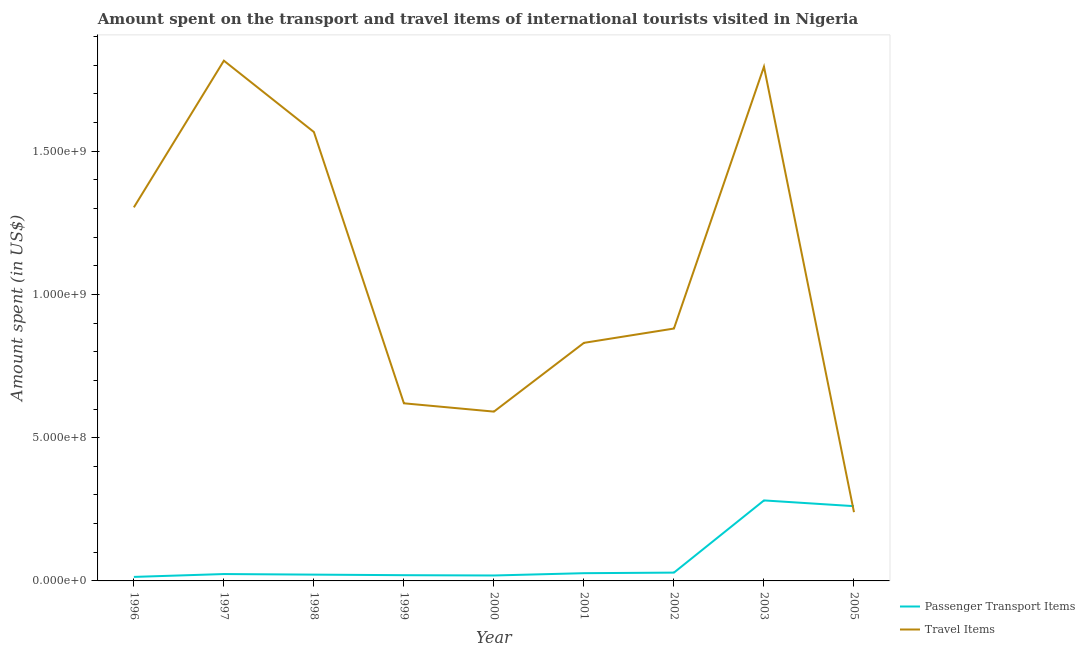How many different coloured lines are there?
Your answer should be compact. 2. Is the number of lines equal to the number of legend labels?
Make the answer very short. Yes. What is the amount spent on passenger transport items in 2002?
Give a very brief answer. 2.90e+07. Across all years, what is the maximum amount spent in travel items?
Offer a very short reply. 1.82e+09. Across all years, what is the minimum amount spent on passenger transport items?
Your response must be concise. 1.40e+07. In which year was the amount spent in travel items maximum?
Your answer should be very brief. 1997. In which year was the amount spent on passenger transport items minimum?
Give a very brief answer. 1996. What is the total amount spent in travel items in the graph?
Give a very brief answer. 9.64e+09. What is the difference between the amount spent in travel items in 2002 and that in 2003?
Provide a succinct answer. -9.14e+08. What is the difference between the amount spent on passenger transport items in 2003 and the amount spent in travel items in 2005?
Your answer should be compact. 4.10e+07. What is the average amount spent on passenger transport items per year?
Your answer should be compact. 7.74e+07. In the year 1996, what is the difference between the amount spent on passenger transport items and amount spent in travel items?
Your answer should be very brief. -1.29e+09. In how many years, is the amount spent in travel items greater than 100000000 US$?
Your answer should be very brief. 9. What is the ratio of the amount spent on passenger transport items in 2000 to that in 2003?
Your answer should be very brief. 0.07. Is the difference between the amount spent on passenger transport items in 2000 and 2002 greater than the difference between the amount spent in travel items in 2000 and 2002?
Your answer should be very brief. Yes. What is the difference between the highest and the second highest amount spent on passenger transport items?
Provide a succinct answer. 2.00e+07. What is the difference between the highest and the lowest amount spent on passenger transport items?
Ensure brevity in your answer.  2.67e+08. Is the amount spent on passenger transport items strictly less than the amount spent in travel items over the years?
Keep it short and to the point. No. How many years are there in the graph?
Ensure brevity in your answer.  9. Does the graph contain any zero values?
Offer a terse response. No. Does the graph contain grids?
Your answer should be very brief. No. Where does the legend appear in the graph?
Keep it short and to the point. Bottom right. How are the legend labels stacked?
Your response must be concise. Vertical. What is the title of the graph?
Your answer should be compact. Amount spent on the transport and travel items of international tourists visited in Nigeria. What is the label or title of the Y-axis?
Ensure brevity in your answer.  Amount spent (in US$). What is the Amount spent (in US$) in Passenger Transport Items in 1996?
Provide a short and direct response. 1.40e+07. What is the Amount spent (in US$) in Travel Items in 1996?
Offer a very short reply. 1.30e+09. What is the Amount spent (in US$) in Passenger Transport Items in 1997?
Provide a succinct answer. 2.40e+07. What is the Amount spent (in US$) in Travel Items in 1997?
Make the answer very short. 1.82e+09. What is the Amount spent (in US$) of Passenger Transport Items in 1998?
Make the answer very short. 2.20e+07. What is the Amount spent (in US$) in Travel Items in 1998?
Your answer should be very brief. 1.57e+09. What is the Amount spent (in US$) of Passenger Transport Items in 1999?
Keep it short and to the point. 2.00e+07. What is the Amount spent (in US$) of Travel Items in 1999?
Offer a terse response. 6.20e+08. What is the Amount spent (in US$) in Passenger Transport Items in 2000?
Give a very brief answer. 1.90e+07. What is the Amount spent (in US$) of Travel Items in 2000?
Ensure brevity in your answer.  5.91e+08. What is the Amount spent (in US$) in Passenger Transport Items in 2001?
Make the answer very short. 2.70e+07. What is the Amount spent (in US$) of Travel Items in 2001?
Offer a very short reply. 8.31e+08. What is the Amount spent (in US$) of Passenger Transport Items in 2002?
Your response must be concise. 2.90e+07. What is the Amount spent (in US$) of Travel Items in 2002?
Your answer should be compact. 8.81e+08. What is the Amount spent (in US$) in Passenger Transport Items in 2003?
Your answer should be very brief. 2.81e+08. What is the Amount spent (in US$) in Travel Items in 2003?
Your response must be concise. 1.80e+09. What is the Amount spent (in US$) of Passenger Transport Items in 2005?
Ensure brevity in your answer.  2.61e+08. What is the Amount spent (in US$) of Travel Items in 2005?
Make the answer very short. 2.40e+08. Across all years, what is the maximum Amount spent (in US$) of Passenger Transport Items?
Your answer should be very brief. 2.81e+08. Across all years, what is the maximum Amount spent (in US$) in Travel Items?
Provide a short and direct response. 1.82e+09. Across all years, what is the minimum Amount spent (in US$) in Passenger Transport Items?
Offer a terse response. 1.40e+07. Across all years, what is the minimum Amount spent (in US$) in Travel Items?
Offer a terse response. 2.40e+08. What is the total Amount spent (in US$) in Passenger Transport Items in the graph?
Provide a short and direct response. 6.97e+08. What is the total Amount spent (in US$) in Travel Items in the graph?
Provide a succinct answer. 9.64e+09. What is the difference between the Amount spent (in US$) in Passenger Transport Items in 1996 and that in 1997?
Make the answer very short. -1.00e+07. What is the difference between the Amount spent (in US$) of Travel Items in 1996 and that in 1997?
Offer a terse response. -5.12e+08. What is the difference between the Amount spent (in US$) of Passenger Transport Items in 1996 and that in 1998?
Keep it short and to the point. -8.00e+06. What is the difference between the Amount spent (in US$) in Travel Items in 1996 and that in 1998?
Your answer should be very brief. -2.63e+08. What is the difference between the Amount spent (in US$) of Passenger Transport Items in 1996 and that in 1999?
Offer a very short reply. -6.00e+06. What is the difference between the Amount spent (in US$) of Travel Items in 1996 and that in 1999?
Offer a very short reply. 6.84e+08. What is the difference between the Amount spent (in US$) in Passenger Transport Items in 1996 and that in 2000?
Give a very brief answer. -5.00e+06. What is the difference between the Amount spent (in US$) of Travel Items in 1996 and that in 2000?
Provide a succinct answer. 7.13e+08. What is the difference between the Amount spent (in US$) of Passenger Transport Items in 1996 and that in 2001?
Give a very brief answer. -1.30e+07. What is the difference between the Amount spent (in US$) in Travel Items in 1996 and that in 2001?
Your response must be concise. 4.73e+08. What is the difference between the Amount spent (in US$) in Passenger Transport Items in 1996 and that in 2002?
Provide a short and direct response. -1.50e+07. What is the difference between the Amount spent (in US$) of Travel Items in 1996 and that in 2002?
Your answer should be compact. 4.23e+08. What is the difference between the Amount spent (in US$) in Passenger Transport Items in 1996 and that in 2003?
Offer a terse response. -2.67e+08. What is the difference between the Amount spent (in US$) of Travel Items in 1996 and that in 2003?
Make the answer very short. -4.91e+08. What is the difference between the Amount spent (in US$) in Passenger Transport Items in 1996 and that in 2005?
Your response must be concise. -2.47e+08. What is the difference between the Amount spent (in US$) of Travel Items in 1996 and that in 2005?
Provide a short and direct response. 1.06e+09. What is the difference between the Amount spent (in US$) of Passenger Transport Items in 1997 and that in 1998?
Make the answer very short. 2.00e+06. What is the difference between the Amount spent (in US$) in Travel Items in 1997 and that in 1998?
Offer a terse response. 2.49e+08. What is the difference between the Amount spent (in US$) of Passenger Transport Items in 1997 and that in 1999?
Your response must be concise. 4.00e+06. What is the difference between the Amount spent (in US$) of Travel Items in 1997 and that in 1999?
Ensure brevity in your answer.  1.20e+09. What is the difference between the Amount spent (in US$) of Travel Items in 1997 and that in 2000?
Make the answer very short. 1.22e+09. What is the difference between the Amount spent (in US$) in Passenger Transport Items in 1997 and that in 2001?
Provide a succinct answer. -3.00e+06. What is the difference between the Amount spent (in US$) of Travel Items in 1997 and that in 2001?
Your answer should be very brief. 9.85e+08. What is the difference between the Amount spent (in US$) of Passenger Transport Items in 1997 and that in 2002?
Offer a very short reply. -5.00e+06. What is the difference between the Amount spent (in US$) in Travel Items in 1997 and that in 2002?
Give a very brief answer. 9.35e+08. What is the difference between the Amount spent (in US$) in Passenger Transport Items in 1997 and that in 2003?
Your answer should be compact. -2.57e+08. What is the difference between the Amount spent (in US$) of Travel Items in 1997 and that in 2003?
Provide a short and direct response. 2.10e+07. What is the difference between the Amount spent (in US$) of Passenger Transport Items in 1997 and that in 2005?
Offer a very short reply. -2.37e+08. What is the difference between the Amount spent (in US$) of Travel Items in 1997 and that in 2005?
Offer a terse response. 1.58e+09. What is the difference between the Amount spent (in US$) in Passenger Transport Items in 1998 and that in 1999?
Make the answer very short. 2.00e+06. What is the difference between the Amount spent (in US$) of Travel Items in 1998 and that in 1999?
Offer a terse response. 9.47e+08. What is the difference between the Amount spent (in US$) in Travel Items in 1998 and that in 2000?
Ensure brevity in your answer.  9.76e+08. What is the difference between the Amount spent (in US$) in Passenger Transport Items in 1998 and that in 2001?
Provide a succinct answer. -5.00e+06. What is the difference between the Amount spent (in US$) of Travel Items in 1998 and that in 2001?
Your response must be concise. 7.36e+08. What is the difference between the Amount spent (in US$) in Passenger Transport Items in 1998 and that in 2002?
Provide a succinct answer. -7.00e+06. What is the difference between the Amount spent (in US$) of Travel Items in 1998 and that in 2002?
Make the answer very short. 6.86e+08. What is the difference between the Amount spent (in US$) of Passenger Transport Items in 1998 and that in 2003?
Your answer should be compact. -2.59e+08. What is the difference between the Amount spent (in US$) of Travel Items in 1998 and that in 2003?
Make the answer very short. -2.28e+08. What is the difference between the Amount spent (in US$) in Passenger Transport Items in 1998 and that in 2005?
Provide a short and direct response. -2.39e+08. What is the difference between the Amount spent (in US$) in Travel Items in 1998 and that in 2005?
Make the answer very short. 1.33e+09. What is the difference between the Amount spent (in US$) of Travel Items in 1999 and that in 2000?
Keep it short and to the point. 2.90e+07. What is the difference between the Amount spent (in US$) of Passenger Transport Items in 1999 and that in 2001?
Your answer should be very brief. -7.00e+06. What is the difference between the Amount spent (in US$) of Travel Items in 1999 and that in 2001?
Offer a terse response. -2.11e+08. What is the difference between the Amount spent (in US$) in Passenger Transport Items in 1999 and that in 2002?
Provide a short and direct response. -9.00e+06. What is the difference between the Amount spent (in US$) of Travel Items in 1999 and that in 2002?
Provide a short and direct response. -2.61e+08. What is the difference between the Amount spent (in US$) of Passenger Transport Items in 1999 and that in 2003?
Your answer should be very brief. -2.61e+08. What is the difference between the Amount spent (in US$) in Travel Items in 1999 and that in 2003?
Make the answer very short. -1.18e+09. What is the difference between the Amount spent (in US$) of Passenger Transport Items in 1999 and that in 2005?
Your response must be concise. -2.41e+08. What is the difference between the Amount spent (in US$) in Travel Items in 1999 and that in 2005?
Offer a very short reply. 3.80e+08. What is the difference between the Amount spent (in US$) in Passenger Transport Items in 2000 and that in 2001?
Provide a succinct answer. -8.00e+06. What is the difference between the Amount spent (in US$) in Travel Items in 2000 and that in 2001?
Offer a terse response. -2.40e+08. What is the difference between the Amount spent (in US$) in Passenger Transport Items in 2000 and that in 2002?
Provide a short and direct response. -1.00e+07. What is the difference between the Amount spent (in US$) of Travel Items in 2000 and that in 2002?
Make the answer very short. -2.90e+08. What is the difference between the Amount spent (in US$) of Passenger Transport Items in 2000 and that in 2003?
Make the answer very short. -2.62e+08. What is the difference between the Amount spent (in US$) in Travel Items in 2000 and that in 2003?
Your answer should be compact. -1.20e+09. What is the difference between the Amount spent (in US$) of Passenger Transport Items in 2000 and that in 2005?
Your answer should be very brief. -2.42e+08. What is the difference between the Amount spent (in US$) in Travel Items in 2000 and that in 2005?
Your response must be concise. 3.51e+08. What is the difference between the Amount spent (in US$) of Passenger Transport Items in 2001 and that in 2002?
Your answer should be compact. -2.00e+06. What is the difference between the Amount spent (in US$) of Travel Items in 2001 and that in 2002?
Your response must be concise. -5.00e+07. What is the difference between the Amount spent (in US$) in Passenger Transport Items in 2001 and that in 2003?
Offer a very short reply. -2.54e+08. What is the difference between the Amount spent (in US$) in Travel Items in 2001 and that in 2003?
Make the answer very short. -9.64e+08. What is the difference between the Amount spent (in US$) in Passenger Transport Items in 2001 and that in 2005?
Offer a terse response. -2.34e+08. What is the difference between the Amount spent (in US$) in Travel Items in 2001 and that in 2005?
Keep it short and to the point. 5.91e+08. What is the difference between the Amount spent (in US$) of Passenger Transport Items in 2002 and that in 2003?
Provide a succinct answer. -2.52e+08. What is the difference between the Amount spent (in US$) of Travel Items in 2002 and that in 2003?
Offer a very short reply. -9.14e+08. What is the difference between the Amount spent (in US$) in Passenger Transport Items in 2002 and that in 2005?
Make the answer very short. -2.32e+08. What is the difference between the Amount spent (in US$) of Travel Items in 2002 and that in 2005?
Provide a succinct answer. 6.41e+08. What is the difference between the Amount spent (in US$) in Travel Items in 2003 and that in 2005?
Offer a terse response. 1.56e+09. What is the difference between the Amount spent (in US$) of Passenger Transport Items in 1996 and the Amount spent (in US$) of Travel Items in 1997?
Keep it short and to the point. -1.80e+09. What is the difference between the Amount spent (in US$) of Passenger Transport Items in 1996 and the Amount spent (in US$) of Travel Items in 1998?
Keep it short and to the point. -1.55e+09. What is the difference between the Amount spent (in US$) of Passenger Transport Items in 1996 and the Amount spent (in US$) of Travel Items in 1999?
Make the answer very short. -6.06e+08. What is the difference between the Amount spent (in US$) in Passenger Transport Items in 1996 and the Amount spent (in US$) in Travel Items in 2000?
Offer a very short reply. -5.77e+08. What is the difference between the Amount spent (in US$) of Passenger Transport Items in 1996 and the Amount spent (in US$) of Travel Items in 2001?
Provide a short and direct response. -8.17e+08. What is the difference between the Amount spent (in US$) of Passenger Transport Items in 1996 and the Amount spent (in US$) of Travel Items in 2002?
Offer a very short reply. -8.67e+08. What is the difference between the Amount spent (in US$) in Passenger Transport Items in 1996 and the Amount spent (in US$) in Travel Items in 2003?
Keep it short and to the point. -1.78e+09. What is the difference between the Amount spent (in US$) in Passenger Transport Items in 1996 and the Amount spent (in US$) in Travel Items in 2005?
Make the answer very short. -2.26e+08. What is the difference between the Amount spent (in US$) of Passenger Transport Items in 1997 and the Amount spent (in US$) of Travel Items in 1998?
Make the answer very short. -1.54e+09. What is the difference between the Amount spent (in US$) of Passenger Transport Items in 1997 and the Amount spent (in US$) of Travel Items in 1999?
Your answer should be very brief. -5.96e+08. What is the difference between the Amount spent (in US$) of Passenger Transport Items in 1997 and the Amount spent (in US$) of Travel Items in 2000?
Your response must be concise. -5.67e+08. What is the difference between the Amount spent (in US$) in Passenger Transport Items in 1997 and the Amount spent (in US$) in Travel Items in 2001?
Offer a very short reply. -8.07e+08. What is the difference between the Amount spent (in US$) of Passenger Transport Items in 1997 and the Amount spent (in US$) of Travel Items in 2002?
Your answer should be compact. -8.57e+08. What is the difference between the Amount spent (in US$) in Passenger Transport Items in 1997 and the Amount spent (in US$) in Travel Items in 2003?
Your answer should be very brief. -1.77e+09. What is the difference between the Amount spent (in US$) of Passenger Transport Items in 1997 and the Amount spent (in US$) of Travel Items in 2005?
Ensure brevity in your answer.  -2.16e+08. What is the difference between the Amount spent (in US$) of Passenger Transport Items in 1998 and the Amount spent (in US$) of Travel Items in 1999?
Keep it short and to the point. -5.98e+08. What is the difference between the Amount spent (in US$) in Passenger Transport Items in 1998 and the Amount spent (in US$) in Travel Items in 2000?
Keep it short and to the point. -5.69e+08. What is the difference between the Amount spent (in US$) in Passenger Transport Items in 1998 and the Amount spent (in US$) in Travel Items in 2001?
Ensure brevity in your answer.  -8.09e+08. What is the difference between the Amount spent (in US$) of Passenger Transport Items in 1998 and the Amount spent (in US$) of Travel Items in 2002?
Your answer should be compact. -8.59e+08. What is the difference between the Amount spent (in US$) in Passenger Transport Items in 1998 and the Amount spent (in US$) in Travel Items in 2003?
Offer a very short reply. -1.77e+09. What is the difference between the Amount spent (in US$) in Passenger Transport Items in 1998 and the Amount spent (in US$) in Travel Items in 2005?
Keep it short and to the point. -2.18e+08. What is the difference between the Amount spent (in US$) of Passenger Transport Items in 1999 and the Amount spent (in US$) of Travel Items in 2000?
Your answer should be very brief. -5.71e+08. What is the difference between the Amount spent (in US$) in Passenger Transport Items in 1999 and the Amount spent (in US$) in Travel Items in 2001?
Keep it short and to the point. -8.11e+08. What is the difference between the Amount spent (in US$) in Passenger Transport Items in 1999 and the Amount spent (in US$) in Travel Items in 2002?
Offer a terse response. -8.61e+08. What is the difference between the Amount spent (in US$) in Passenger Transport Items in 1999 and the Amount spent (in US$) in Travel Items in 2003?
Offer a very short reply. -1.78e+09. What is the difference between the Amount spent (in US$) of Passenger Transport Items in 1999 and the Amount spent (in US$) of Travel Items in 2005?
Offer a terse response. -2.20e+08. What is the difference between the Amount spent (in US$) in Passenger Transport Items in 2000 and the Amount spent (in US$) in Travel Items in 2001?
Keep it short and to the point. -8.12e+08. What is the difference between the Amount spent (in US$) in Passenger Transport Items in 2000 and the Amount spent (in US$) in Travel Items in 2002?
Your response must be concise. -8.62e+08. What is the difference between the Amount spent (in US$) of Passenger Transport Items in 2000 and the Amount spent (in US$) of Travel Items in 2003?
Keep it short and to the point. -1.78e+09. What is the difference between the Amount spent (in US$) in Passenger Transport Items in 2000 and the Amount spent (in US$) in Travel Items in 2005?
Offer a terse response. -2.21e+08. What is the difference between the Amount spent (in US$) in Passenger Transport Items in 2001 and the Amount spent (in US$) in Travel Items in 2002?
Offer a terse response. -8.54e+08. What is the difference between the Amount spent (in US$) of Passenger Transport Items in 2001 and the Amount spent (in US$) of Travel Items in 2003?
Ensure brevity in your answer.  -1.77e+09. What is the difference between the Amount spent (in US$) of Passenger Transport Items in 2001 and the Amount spent (in US$) of Travel Items in 2005?
Your response must be concise. -2.13e+08. What is the difference between the Amount spent (in US$) in Passenger Transport Items in 2002 and the Amount spent (in US$) in Travel Items in 2003?
Your response must be concise. -1.77e+09. What is the difference between the Amount spent (in US$) of Passenger Transport Items in 2002 and the Amount spent (in US$) of Travel Items in 2005?
Your response must be concise. -2.11e+08. What is the difference between the Amount spent (in US$) in Passenger Transport Items in 2003 and the Amount spent (in US$) in Travel Items in 2005?
Offer a very short reply. 4.10e+07. What is the average Amount spent (in US$) of Passenger Transport Items per year?
Offer a terse response. 7.74e+07. What is the average Amount spent (in US$) of Travel Items per year?
Offer a very short reply. 1.07e+09. In the year 1996, what is the difference between the Amount spent (in US$) in Passenger Transport Items and Amount spent (in US$) in Travel Items?
Provide a short and direct response. -1.29e+09. In the year 1997, what is the difference between the Amount spent (in US$) in Passenger Transport Items and Amount spent (in US$) in Travel Items?
Provide a succinct answer. -1.79e+09. In the year 1998, what is the difference between the Amount spent (in US$) of Passenger Transport Items and Amount spent (in US$) of Travel Items?
Offer a terse response. -1.54e+09. In the year 1999, what is the difference between the Amount spent (in US$) in Passenger Transport Items and Amount spent (in US$) in Travel Items?
Make the answer very short. -6.00e+08. In the year 2000, what is the difference between the Amount spent (in US$) in Passenger Transport Items and Amount spent (in US$) in Travel Items?
Give a very brief answer. -5.72e+08. In the year 2001, what is the difference between the Amount spent (in US$) of Passenger Transport Items and Amount spent (in US$) of Travel Items?
Your answer should be very brief. -8.04e+08. In the year 2002, what is the difference between the Amount spent (in US$) of Passenger Transport Items and Amount spent (in US$) of Travel Items?
Offer a very short reply. -8.52e+08. In the year 2003, what is the difference between the Amount spent (in US$) of Passenger Transport Items and Amount spent (in US$) of Travel Items?
Provide a short and direct response. -1.51e+09. In the year 2005, what is the difference between the Amount spent (in US$) in Passenger Transport Items and Amount spent (in US$) in Travel Items?
Your answer should be very brief. 2.10e+07. What is the ratio of the Amount spent (in US$) of Passenger Transport Items in 1996 to that in 1997?
Make the answer very short. 0.58. What is the ratio of the Amount spent (in US$) of Travel Items in 1996 to that in 1997?
Ensure brevity in your answer.  0.72. What is the ratio of the Amount spent (in US$) in Passenger Transport Items in 1996 to that in 1998?
Ensure brevity in your answer.  0.64. What is the ratio of the Amount spent (in US$) in Travel Items in 1996 to that in 1998?
Keep it short and to the point. 0.83. What is the ratio of the Amount spent (in US$) of Travel Items in 1996 to that in 1999?
Provide a short and direct response. 2.1. What is the ratio of the Amount spent (in US$) in Passenger Transport Items in 1996 to that in 2000?
Provide a short and direct response. 0.74. What is the ratio of the Amount spent (in US$) in Travel Items in 1996 to that in 2000?
Keep it short and to the point. 2.21. What is the ratio of the Amount spent (in US$) in Passenger Transport Items in 1996 to that in 2001?
Ensure brevity in your answer.  0.52. What is the ratio of the Amount spent (in US$) of Travel Items in 1996 to that in 2001?
Your answer should be compact. 1.57. What is the ratio of the Amount spent (in US$) of Passenger Transport Items in 1996 to that in 2002?
Ensure brevity in your answer.  0.48. What is the ratio of the Amount spent (in US$) of Travel Items in 1996 to that in 2002?
Ensure brevity in your answer.  1.48. What is the ratio of the Amount spent (in US$) of Passenger Transport Items in 1996 to that in 2003?
Make the answer very short. 0.05. What is the ratio of the Amount spent (in US$) in Travel Items in 1996 to that in 2003?
Provide a short and direct response. 0.73. What is the ratio of the Amount spent (in US$) of Passenger Transport Items in 1996 to that in 2005?
Keep it short and to the point. 0.05. What is the ratio of the Amount spent (in US$) in Travel Items in 1996 to that in 2005?
Give a very brief answer. 5.43. What is the ratio of the Amount spent (in US$) in Passenger Transport Items in 1997 to that in 1998?
Offer a very short reply. 1.09. What is the ratio of the Amount spent (in US$) in Travel Items in 1997 to that in 1998?
Offer a terse response. 1.16. What is the ratio of the Amount spent (in US$) in Travel Items in 1997 to that in 1999?
Offer a terse response. 2.93. What is the ratio of the Amount spent (in US$) of Passenger Transport Items in 1997 to that in 2000?
Keep it short and to the point. 1.26. What is the ratio of the Amount spent (in US$) of Travel Items in 1997 to that in 2000?
Give a very brief answer. 3.07. What is the ratio of the Amount spent (in US$) in Passenger Transport Items in 1997 to that in 2001?
Your answer should be very brief. 0.89. What is the ratio of the Amount spent (in US$) in Travel Items in 1997 to that in 2001?
Your answer should be compact. 2.19. What is the ratio of the Amount spent (in US$) in Passenger Transport Items in 1997 to that in 2002?
Provide a short and direct response. 0.83. What is the ratio of the Amount spent (in US$) of Travel Items in 1997 to that in 2002?
Give a very brief answer. 2.06. What is the ratio of the Amount spent (in US$) of Passenger Transport Items in 1997 to that in 2003?
Your answer should be compact. 0.09. What is the ratio of the Amount spent (in US$) in Travel Items in 1997 to that in 2003?
Offer a very short reply. 1.01. What is the ratio of the Amount spent (in US$) of Passenger Transport Items in 1997 to that in 2005?
Your answer should be compact. 0.09. What is the ratio of the Amount spent (in US$) in Travel Items in 1997 to that in 2005?
Keep it short and to the point. 7.57. What is the ratio of the Amount spent (in US$) of Travel Items in 1998 to that in 1999?
Your response must be concise. 2.53. What is the ratio of the Amount spent (in US$) of Passenger Transport Items in 1998 to that in 2000?
Offer a very short reply. 1.16. What is the ratio of the Amount spent (in US$) in Travel Items in 1998 to that in 2000?
Give a very brief answer. 2.65. What is the ratio of the Amount spent (in US$) in Passenger Transport Items in 1998 to that in 2001?
Your response must be concise. 0.81. What is the ratio of the Amount spent (in US$) of Travel Items in 1998 to that in 2001?
Keep it short and to the point. 1.89. What is the ratio of the Amount spent (in US$) in Passenger Transport Items in 1998 to that in 2002?
Provide a succinct answer. 0.76. What is the ratio of the Amount spent (in US$) in Travel Items in 1998 to that in 2002?
Give a very brief answer. 1.78. What is the ratio of the Amount spent (in US$) of Passenger Transport Items in 1998 to that in 2003?
Your answer should be very brief. 0.08. What is the ratio of the Amount spent (in US$) in Travel Items in 1998 to that in 2003?
Offer a very short reply. 0.87. What is the ratio of the Amount spent (in US$) in Passenger Transport Items in 1998 to that in 2005?
Offer a very short reply. 0.08. What is the ratio of the Amount spent (in US$) of Travel Items in 1998 to that in 2005?
Your response must be concise. 6.53. What is the ratio of the Amount spent (in US$) of Passenger Transport Items in 1999 to that in 2000?
Offer a terse response. 1.05. What is the ratio of the Amount spent (in US$) of Travel Items in 1999 to that in 2000?
Make the answer very short. 1.05. What is the ratio of the Amount spent (in US$) in Passenger Transport Items in 1999 to that in 2001?
Ensure brevity in your answer.  0.74. What is the ratio of the Amount spent (in US$) in Travel Items in 1999 to that in 2001?
Make the answer very short. 0.75. What is the ratio of the Amount spent (in US$) in Passenger Transport Items in 1999 to that in 2002?
Offer a terse response. 0.69. What is the ratio of the Amount spent (in US$) of Travel Items in 1999 to that in 2002?
Make the answer very short. 0.7. What is the ratio of the Amount spent (in US$) of Passenger Transport Items in 1999 to that in 2003?
Make the answer very short. 0.07. What is the ratio of the Amount spent (in US$) in Travel Items in 1999 to that in 2003?
Offer a very short reply. 0.35. What is the ratio of the Amount spent (in US$) in Passenger Transport Items in 1999 to that in 2005?
Make the answer very short. 0.08. What is the ratio of the Amount spent (in US$) in Travel Items in 1999 to that in 2005?
Provide a short and direct response. 2.58. What is the ratio of the Amount spent (in US$) in Passenger Transport Items in 2000 to that in 2001?
Give a very brief answer. 0.7. What is the ratio of the Amount spent (in US$) of Travel Items in 2000 to that in 2001?
Provide a succinct answer. 0.71. What is the ratio of the Amount spent (in US$) in Passenger Transport Items in 2000 to that in 2002?
Give a very brief answer. 0.66. What is the ratio of the Amount spent (in US$) in Travel Items in 2000 to that in 2002?
Your answer should be compact. 0.67. What is the ratio of the Amount spent (in US$) in Passenger Transport Items in 2000 to that in 2003?
Offer a terse response. 0.07. What is the ratio of the Amount spent (in US$) of Travel Items in 2000 to that in 2003?
Keep it short and to the point. 0.33. What is the ratio of the Amount spent (in US$) of Passenger Transport Items in 2000 to that in 2005?
Make the answer very short. 0.07. What is the ratio of the Amount spent (in US$) in Travel Items in 2000 to that in 2005?
Keep it short and to the point. 2.46. What is the ratio of the Amount spent (in US$) of Travel Items in 2001 to that in 2002?
Provide a succinct answer. 0.94. What is the ratio of the Amount spent (in US$) of Passenger Transport Items in 2001 to that in 2003?
Make the answer very short. 0.1. What is the ratio of the Amount spent (in US$) in Travel Items in 2001 to that in 2003?
Your answer should be compact. 0.46. What is the ratio of the Amount spent (in US$) in Passenger Transport Items in 2001 to that in 2005?
Offer a terse response. 0.1. What is the ratio of the Amount spent (in US$) of Travel Items in 2001 to that in 2005?
Your response must be concise. 3.46. What is the ratio of the Amount spent (in US$) in Passenger Transport Items in 2002 to that in 2003?
Offer a very short reply. 0.1. What is the ratio of the Amount spent (in US$) of Travel Items in 2002 to that in 2003?
Your answer should be very brief. 0.49. What is the ratio of the Amount spent (in US$) in Travel Items in 2002 to that in 2005?
Offer a terse response. 3.67. What is the ratio of the Amount spent (in US$) of Passenger Transport Items in 2003 to that in 2005?
Make the answer very short. 1.08. What is the ratio of the Amount spent (in US$) of Travel Items in 2003 to that in 2005?
Ensure brevity in your answer.  7.48. What is the difference between the highest and the second highest Amount spent (in US$) of Passenger Transport Items?
Make the answer very short. 2.00e+07. What is the difference between the highest and the second highest Amount spent (in US$) in Travel Items?
Make the answer very short. 2.10e+07. What is the difference between the highest and the lowest Amount spent (in US$) in Passenger Transport Items?
Your answer should be compact. 2.67e+08. What is the difference between the highest and the lowest Amount spent (in US$) in Travel Items?
Give a very brief answer. 1.58e+09. 